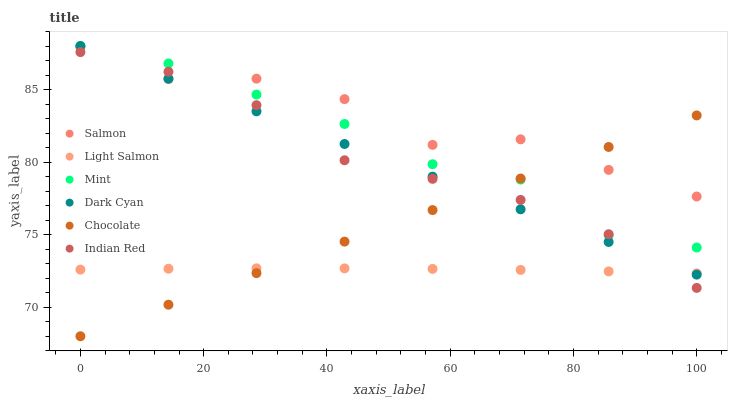Does Light Salmon have the minimum area under the curve?
Answer yes or no. Yes. Does Salmon have the maximum area under the curve?
Answer yes or no. Yes. Does Chocolate have the minimum area under the curve?
Answer yes or no. No. Does Chocolate have the maximum area under the curve?
Answer yes or no. No. Is Chocolate the smoothest?
Answer yes or no. Yes. Is Salmon the roughest?
Answer yes or no. Yes. Is Salmon the smoothest?
Answer yes or no. No. Is Chocolate the roughest?
Answer yes or no. No. Does Chocolate have the lowest value?
Answer yes or no. Yes. Does Salmon have the lowest value?
Answer yes or no. No. Does Mint have the highest value?
Answer yes or no. Yes. Does Salmon have the highest value?
Answer yes or no. No. Is Light Salmon less than Mint?
Answer yes or no. Yes. Is Salmon greater than Light Salmon?
Answer yes or no. Yes. Does Mint intersect Indian Red?
Answer yes or no. Yes. Is Mint less than Indian Red?
Answer yes or no. No. Is Mint greater than Indian Red?
Answer yes or no. No. Does Light Salmon intersect Mint?
Answer yes or no. No. 